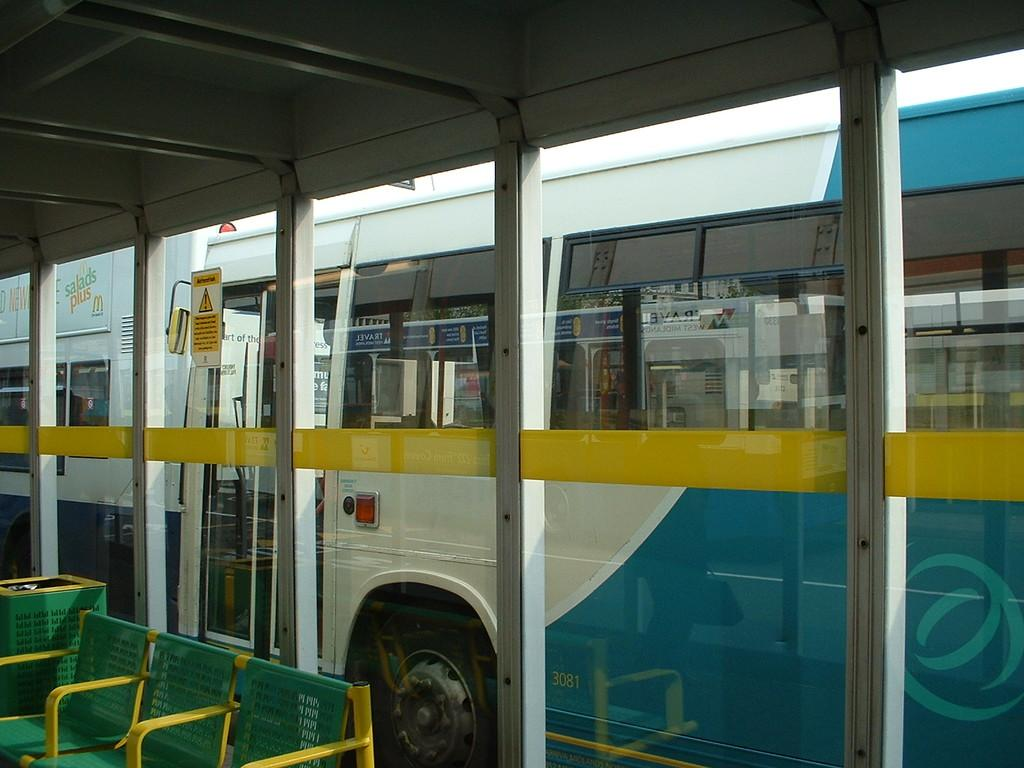What mode of transportation can be seen in the image? There is a bus visible in the image. From where is the bus being viewed? The bus is seen from a window. What type of furniture is present in the image? There are chairs in the image. What object is used for waste disposal in the image? There is a dustbin in the image. What type of mint is being used to garnish the drink in the image? There is no drink or mint present in the image. 